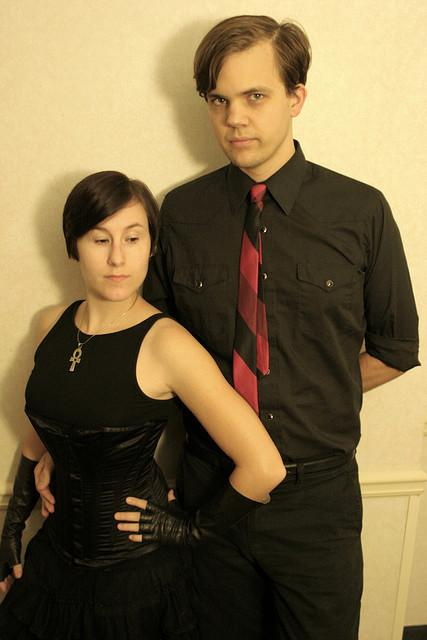What's the name of the pendant on the woman's necklace?

Choices:
A) dagger
B) ankh
C) staff
D) cross ankh 